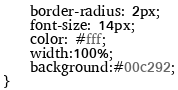<code> <loc_0><loc_0><loc_500><loc_500><_CSS_>    border-radius: 2px;
    font-size: 14px;
    color: #fff;
	width:100%;
	background:#00c292;
}</code> 